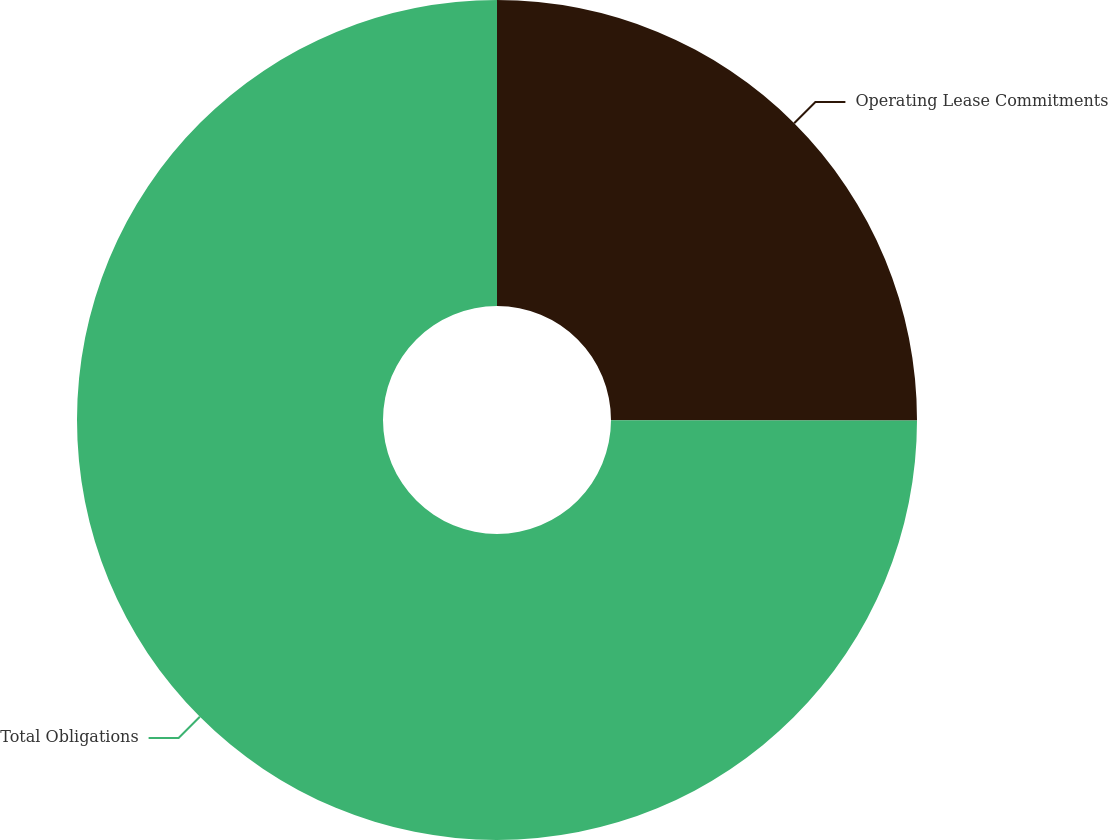Convert chart. <chart><loc_0><loc_0><loc_500><loc_500><pie_chart><fcel>Operating Lease Commitments<fcel>Total Obligations<nl><fcel>25.02%<fcel>74.98%<nl></chart> 